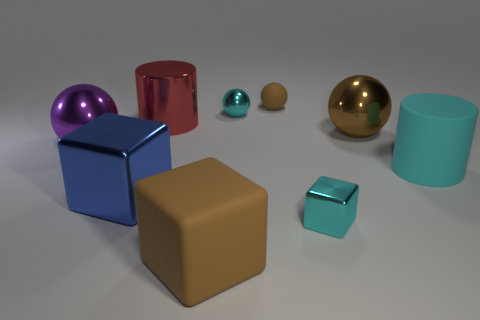Subtract all tiny cubes. How many cubes are left? 2 Subtract all cubes. How many objects are left? 6 Subtract all red cylinders. How many cylinders are left? 1 Subtract all cyan spheres. How many cyan cylinders are left? 1 Subtract 0 green cylinders. How many objects are left? 9 Subtract 1 cubes. How many cubes are left? 2 Subtract all cyan balls. Subtract all brown blocks. How many balls are left? 3 Subtract all big blue shiny objects. Subtract all small gray matte cubes. How many objects are left? 8 Add 6 big red metallic cylinders. How many big red metallic cylinders are left? 7 Add 7 large purple metal balls. How many large purple metal balls exist? 8 